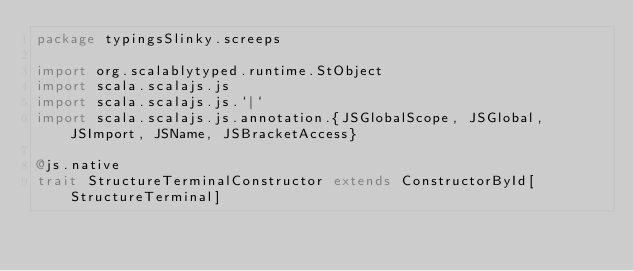<code> <loc_0><loc_0><loc_500><loc_500><_Scala_>package typingsSlinky.screeps

import org.scalablytyped.runtime.StObject
import scala.scalajs.js
import scala.scalajs.js.`|`
import scala.scalajs.js.annotation.{JSGlobalScope, JSGlobal, JSImport, JSName, JSBracketAccess}

@js.native
trait StructureTerminalConstructor extends ConstructorById[StructureTerminal]
</code> 